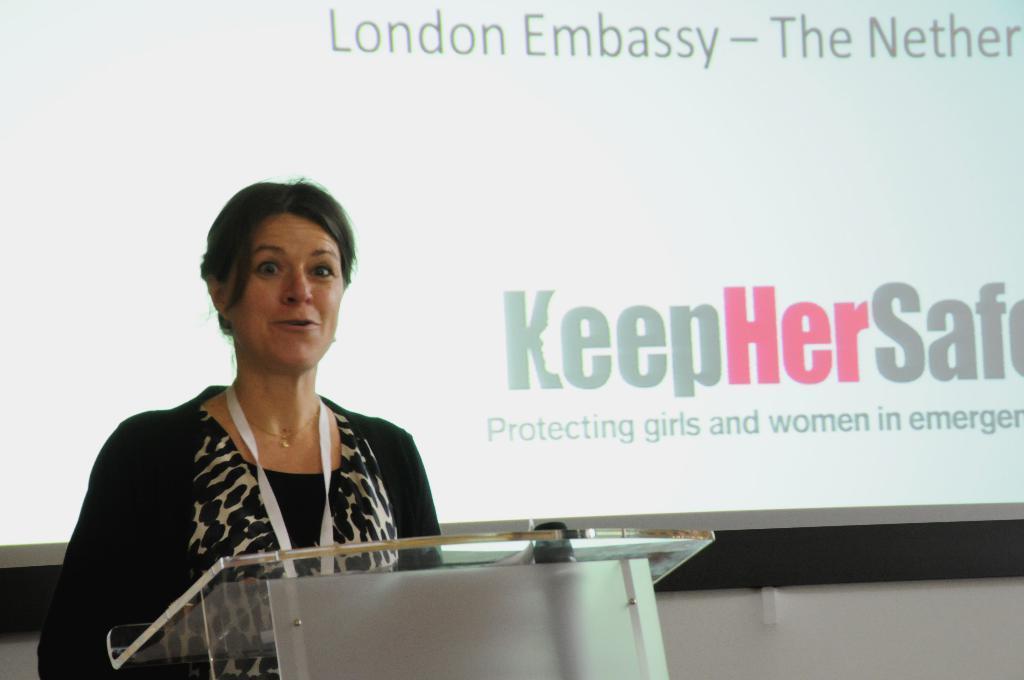Describe this image in one or two sentences. On the left side of the image we can see a lady is standing in-front of podium and talking. In the background of the image we can see the wall and board. 